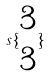<formula> <loc_0><loc_0><loc_500><loc_500>s \{ \begin{matrix} 3 \\ 3 \end{matrix} \}</formula> 